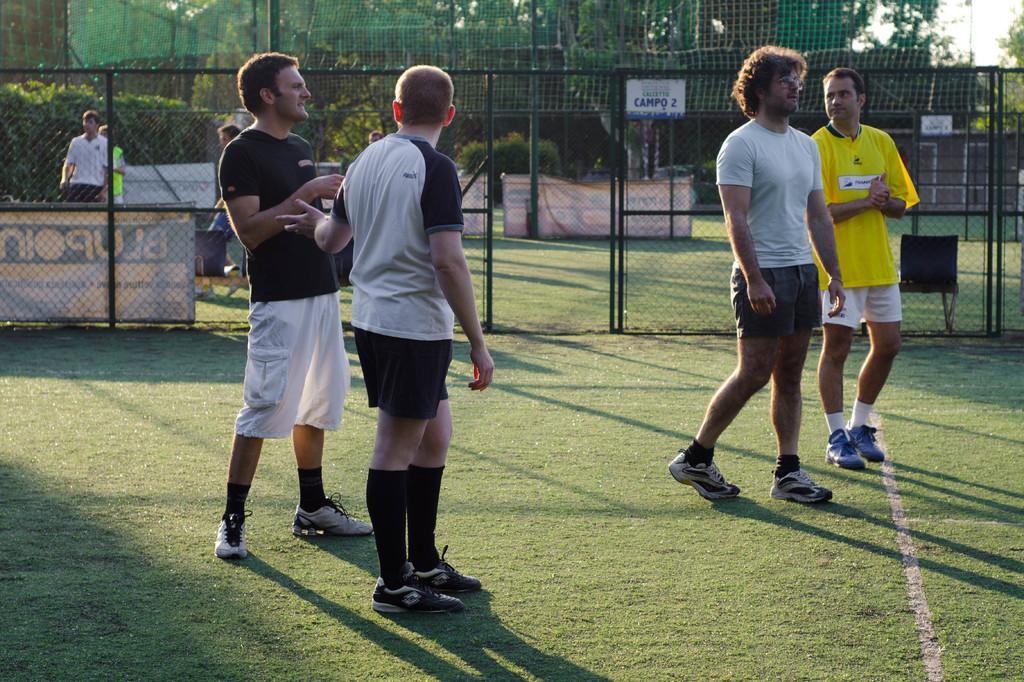Please provide a concise description of this image. In the image there are four men in shorts and t-shirt standing on the grass land with shoe to their feet, in the back there is fence followed by many trees in the background, few people standing on the left side. 